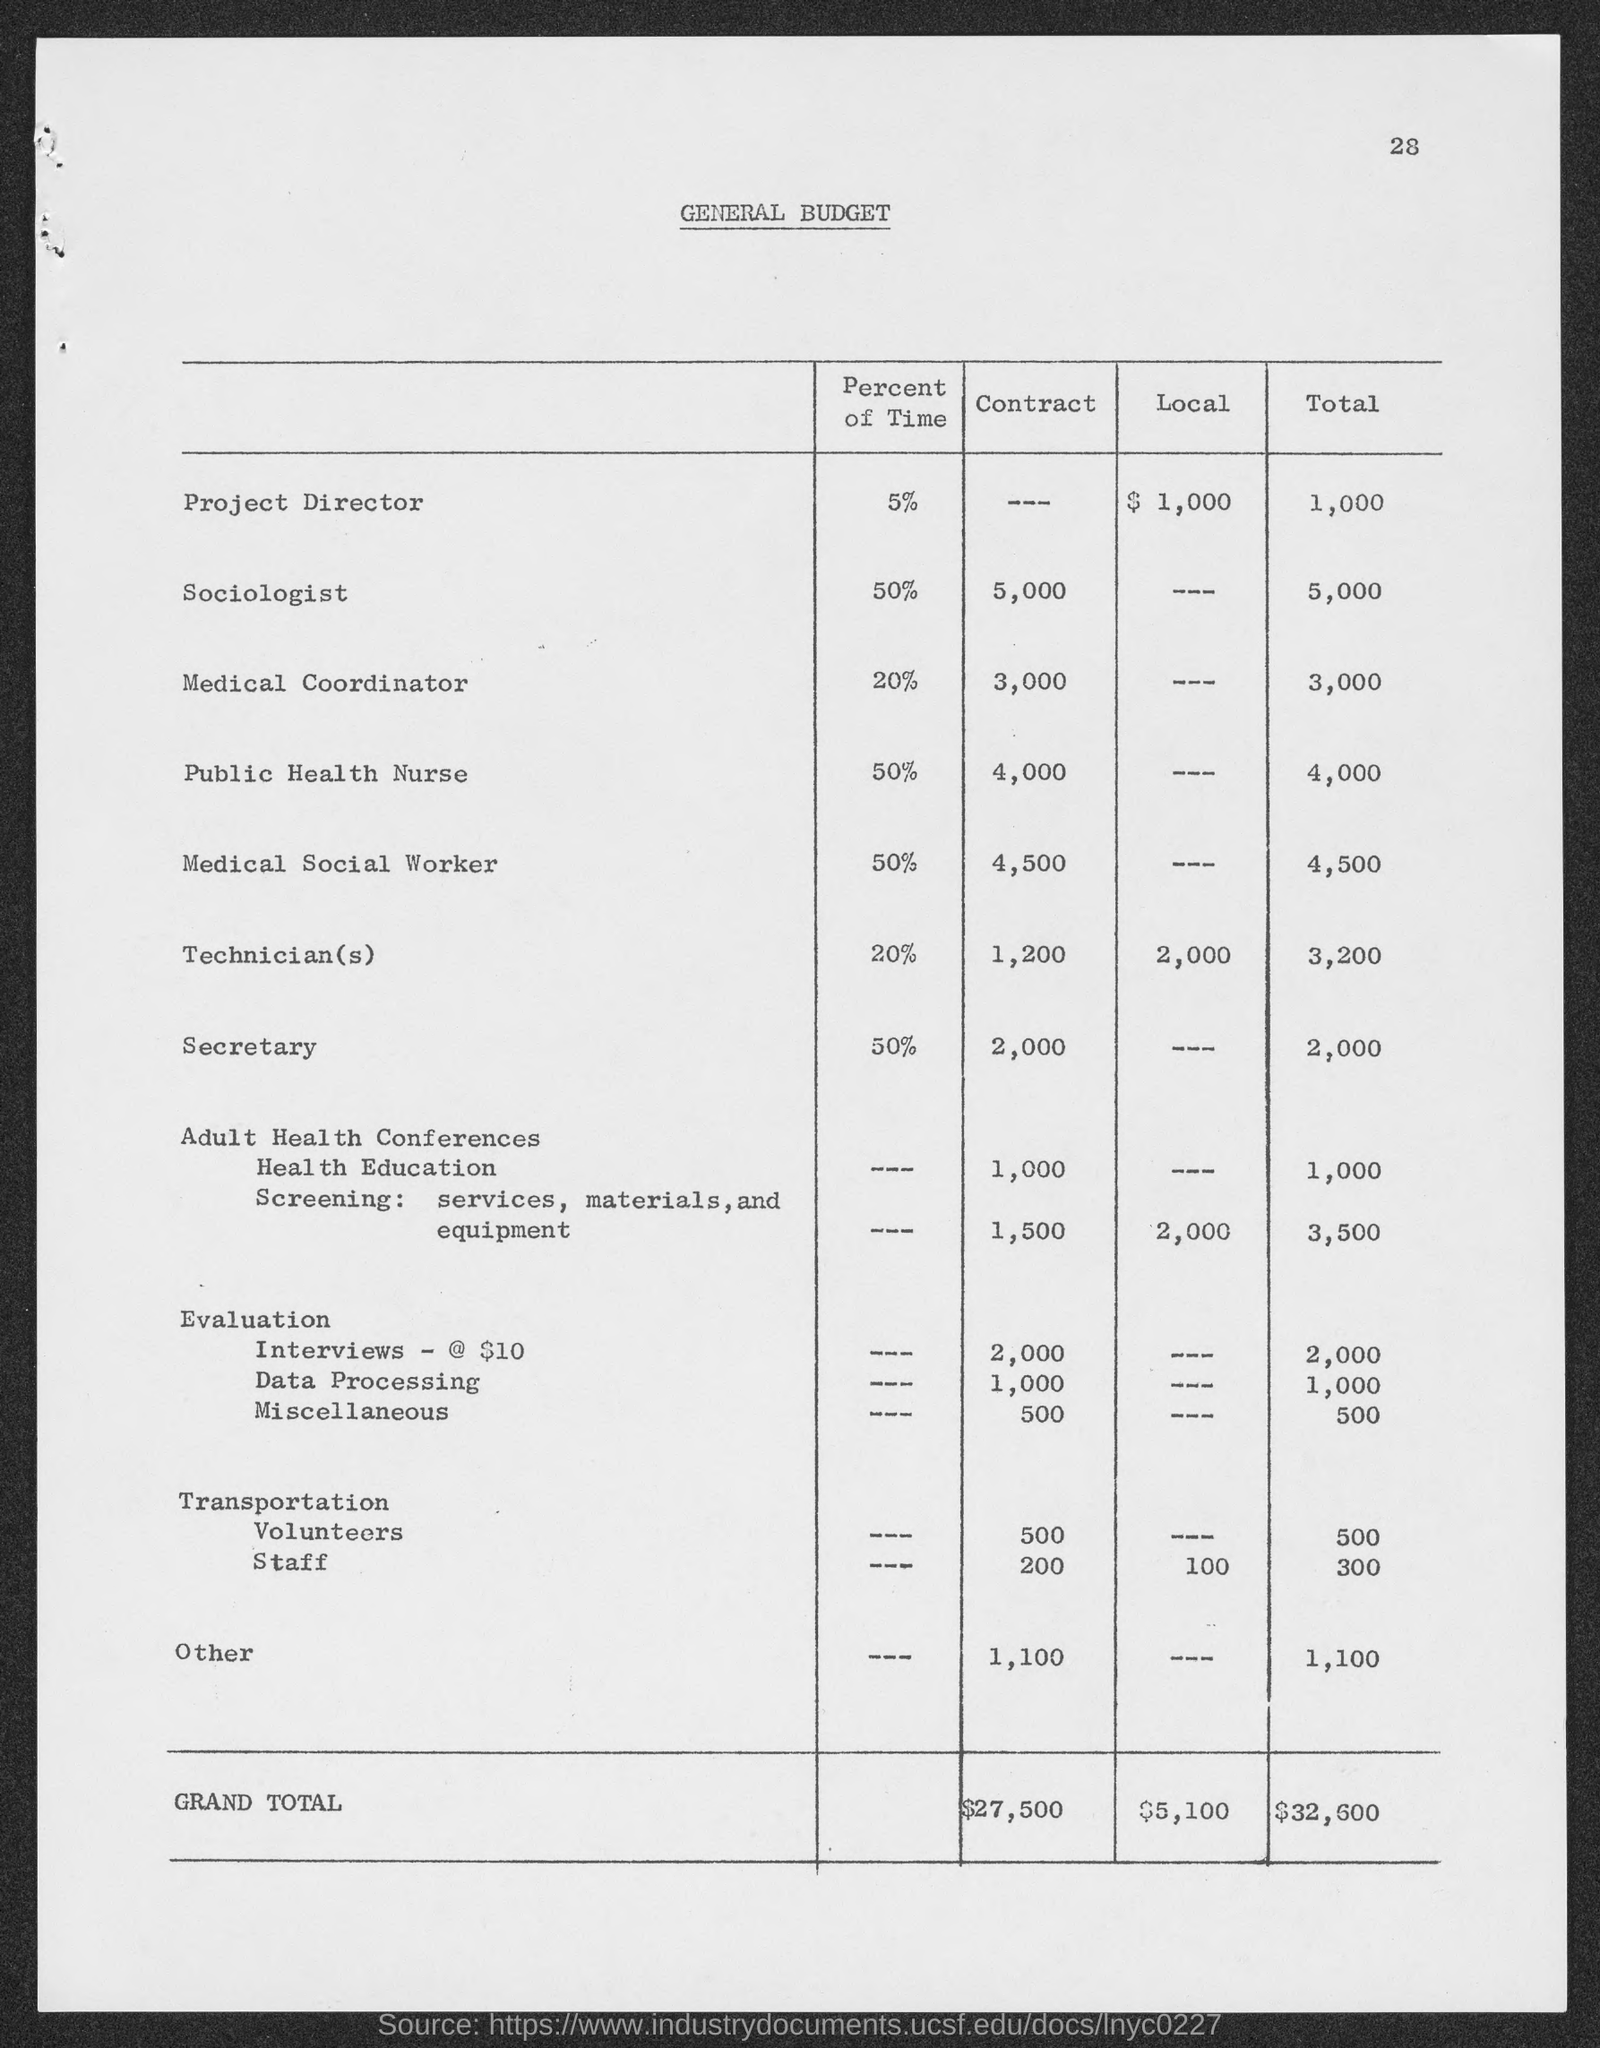what is the general budget total for Medical Coordinator? The general budget total allocated for the Medical Coordinator is $3,000. This amount is specified under the 'Contract' column, without any local contributions, resulting in a total budget of $3,000 for that role. 